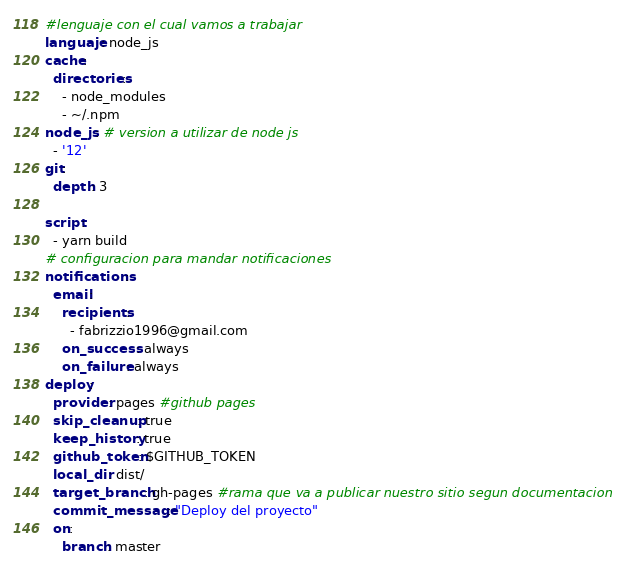<code> <loc_0><loc_0><loc_500><loc_500><_YAML_>#lenguaje con el cual vamos a trabajar
languaje: node_js
cache:
  directories:
    - node_modules
    - ~/.npm
node_js: # version a utilizar de node js
  - '12' 
git:
  depth: 3

script:
  - yarn build
# configuracion para mandar notificaciones
notifications:
  email:
    recipients:
      - fabrizzio1996@gmail.com
    on_success: always
    on_failure: always  
deploy:
  provider: pages #github pages
  skip_cleanup: true
  keep_history: true
  github_token: $GITHUB_TOKEN
  local_dir: dist/
  target_branch: gh-pages #rama que va a publicar nuestro sitio segun documentacion
  commit_message: "Deploy del proyecto"
  on:
    branch: master



</code> 